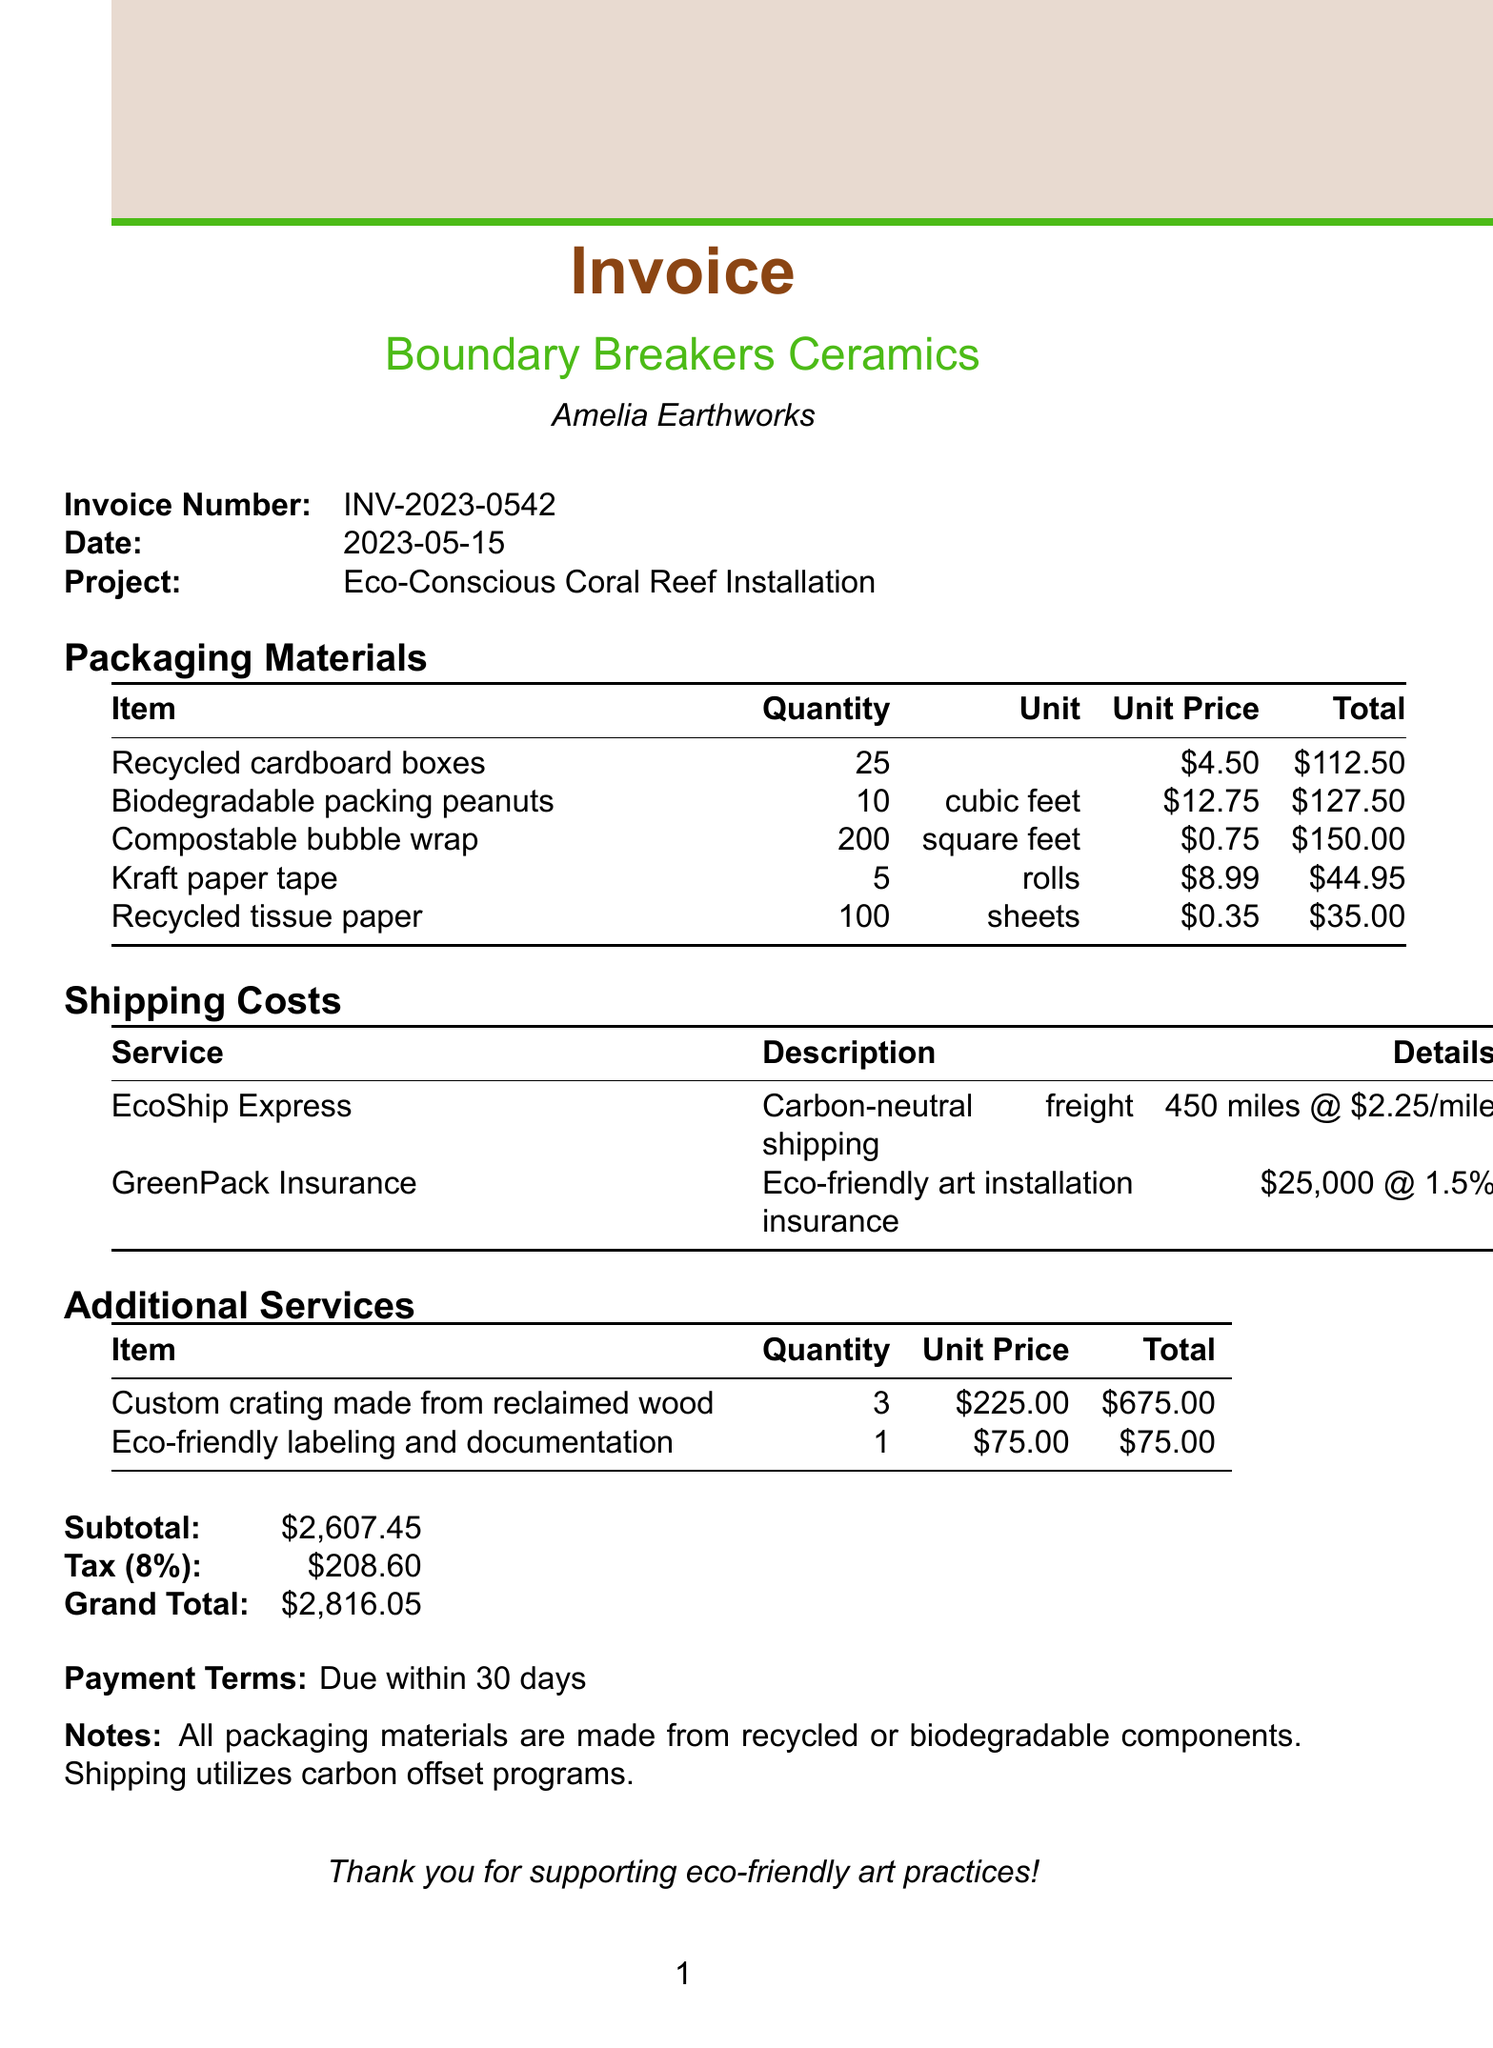What is the artist's name? The artist's name is clearly listed at the beginning of the document under invoice details.
Answer: Amelia Earthworks What is the invoice number? The invoice number is presented in the invoice details section.
Answer: INV-2023-0542 What is the total cost for biodegradable packing peanuts? The total cost is provided in the packaging materials section for biodegradable packing peanuts.
Answer: 127.50 How many recycled cardboard boxes were purchased? The quantity of recycled cardboard boxes is specified in the packaging materials section.
Answer: 25 What is the grand total for the invoice? The grand total is the final amount calculated at the end of the invoice.
Answer: 2816.05 What is the distance for the EcoShip Express shipping service? The distance for the shipping service is detailed under the shipping costs section.
Answer: 450 miles How much is charged per mile for shipping? The rate per mile is mentioned in the shipping costs section regarding EcoShip Express.
Answer: 2.25 What type of paper is used for tape? The specific type of tape is mentioned in the packaging materials section.
Answer: Kraft paper tape When is the payment due? The payment terms offer clear information on when payment should be made.
Answer: Due within 30 days 